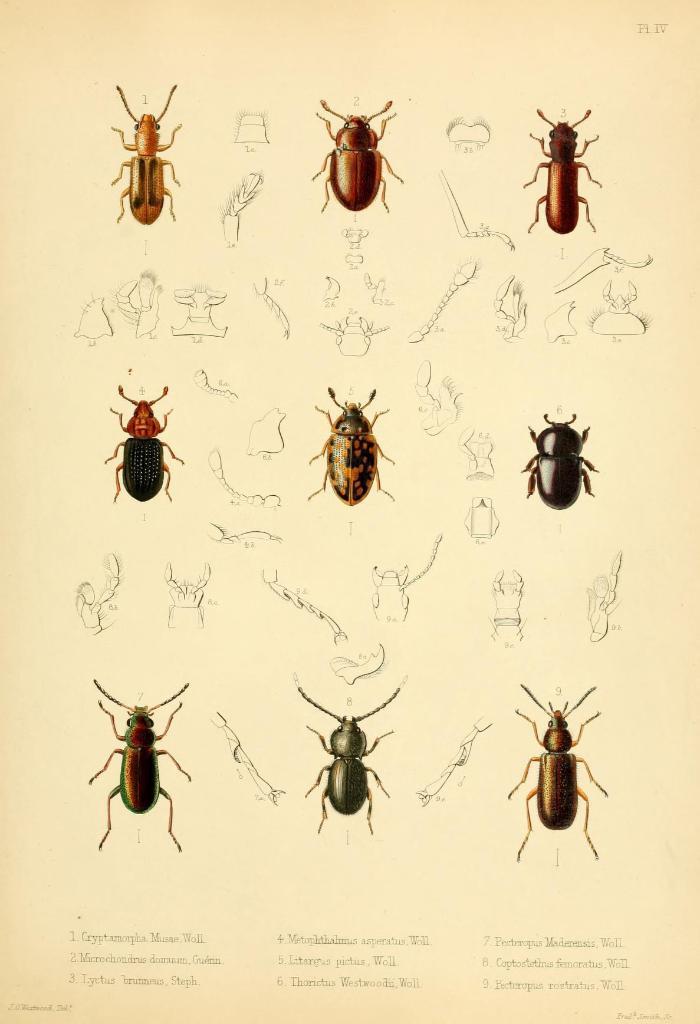Could you give a brief overview of what you see in this image? This is the picture of an art. In this picture, we see the insects and these insects are in black, red and brown color. At the bottom, we see some text written on the paper. In the background, it is white in color and this might be a paper. 